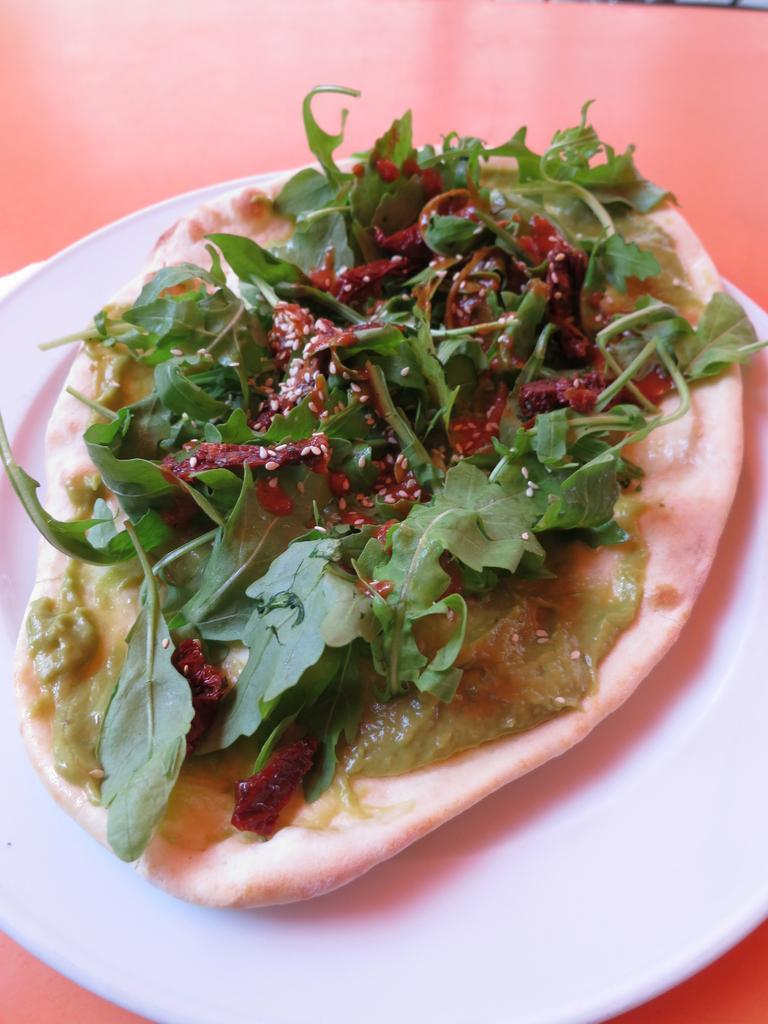Could you give a brief overview of what you see in this image? In the picture we can see a white color plate on it we can see a cream and on it we can see some leafy vegetables. 